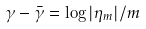Convert formula to latex. <formula><loc_0><loc_0><loc_500><loc_500>\gamma - \bar { \gamma } = \log | \eta _ { m } | / m</formula> 